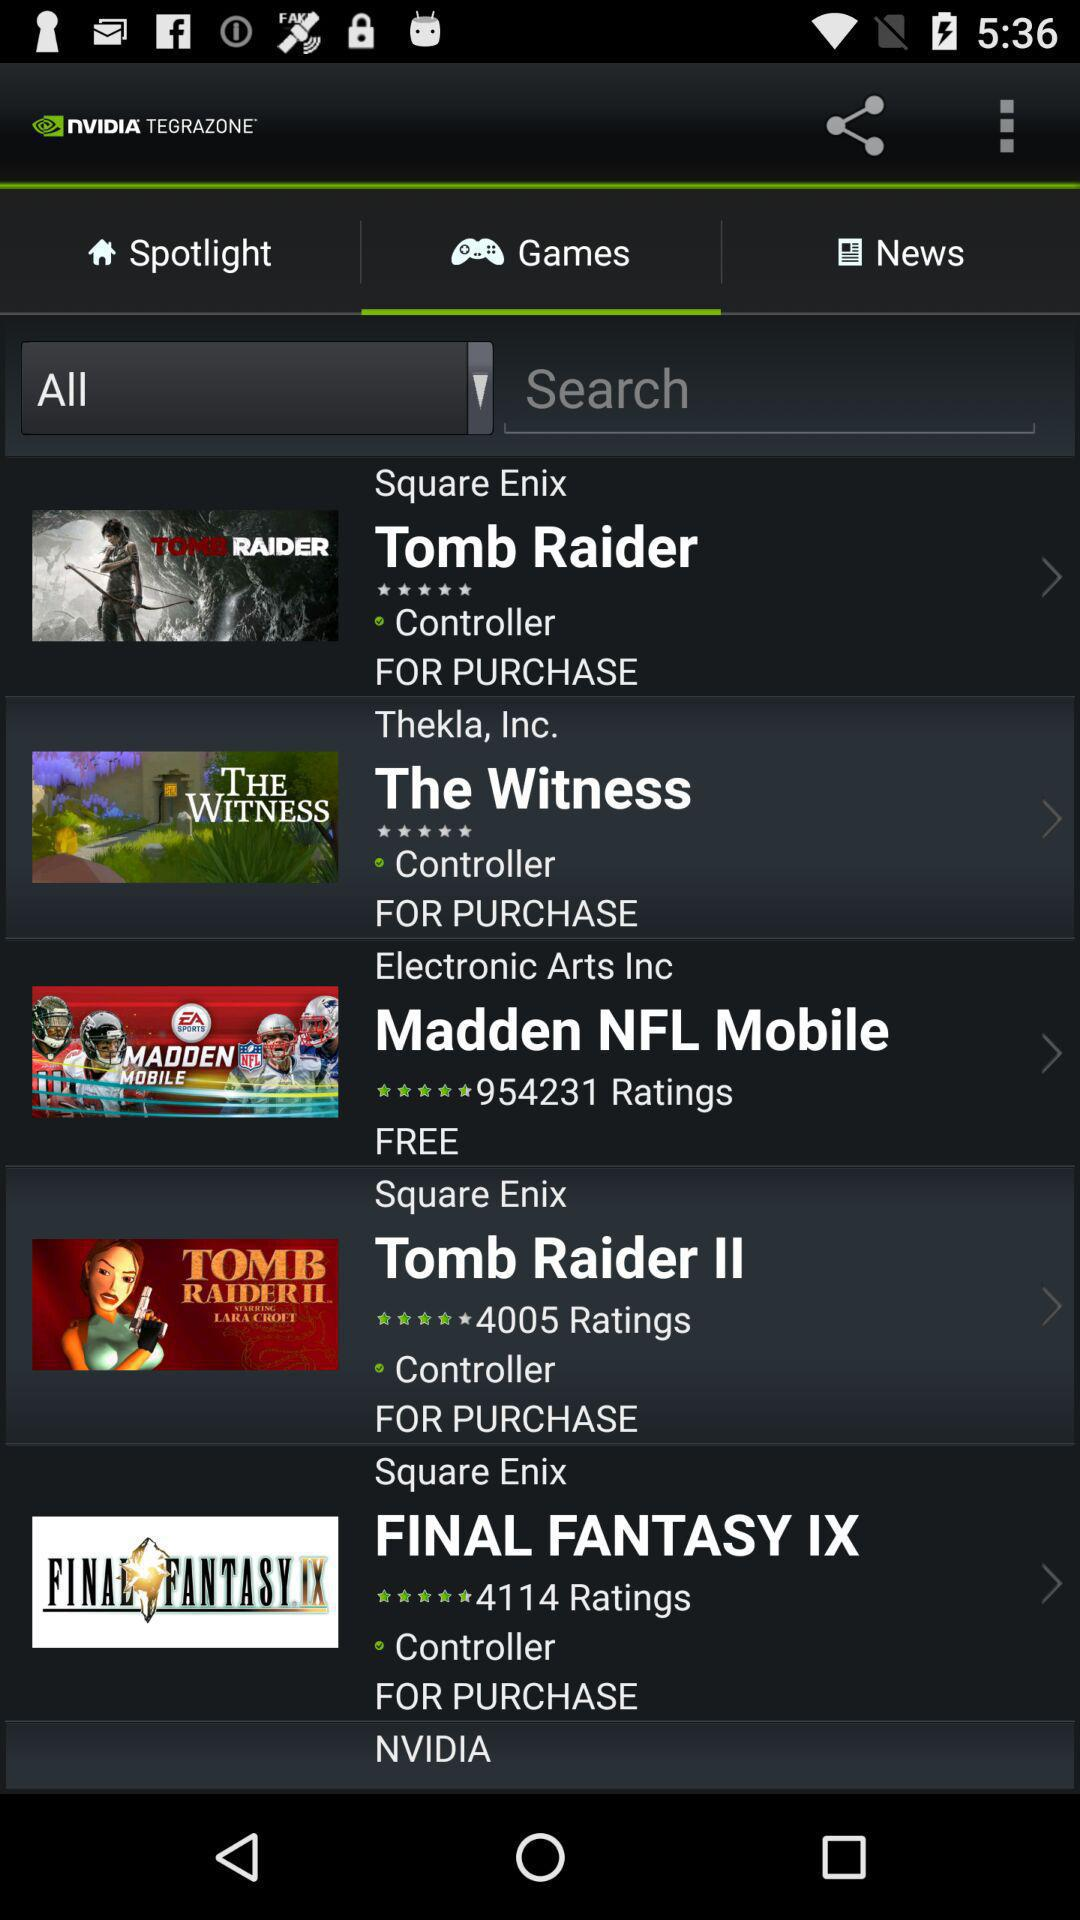How many ratings are given to the "Madden NFL Mobile"? The rating is 4.5 stars. 